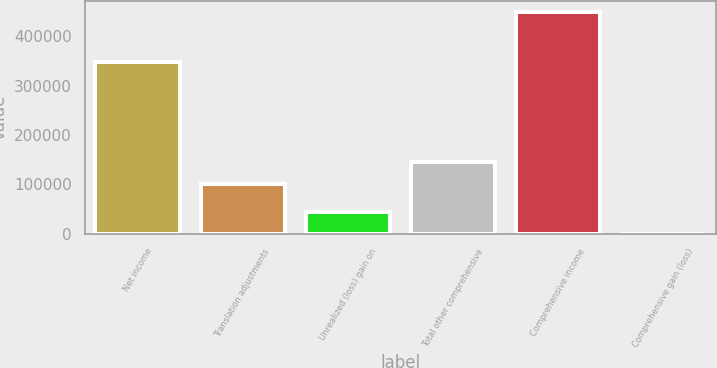Convert chart. <chart><loc_0><loc_0><loc_500><loc_500><bar_chart><fcel>Net income<fcel>Translation adjustments<fcel>Unrealized (loss) gain on<fcel>Total other comprehensive<fcel>Comprehensive income<fcel>Comprehensive gain (loss)<nl><fcel>347588<fcel>100999<fcel>44910.6<fcel>145879<fcel>448796<fcel>31<nl></chart> 